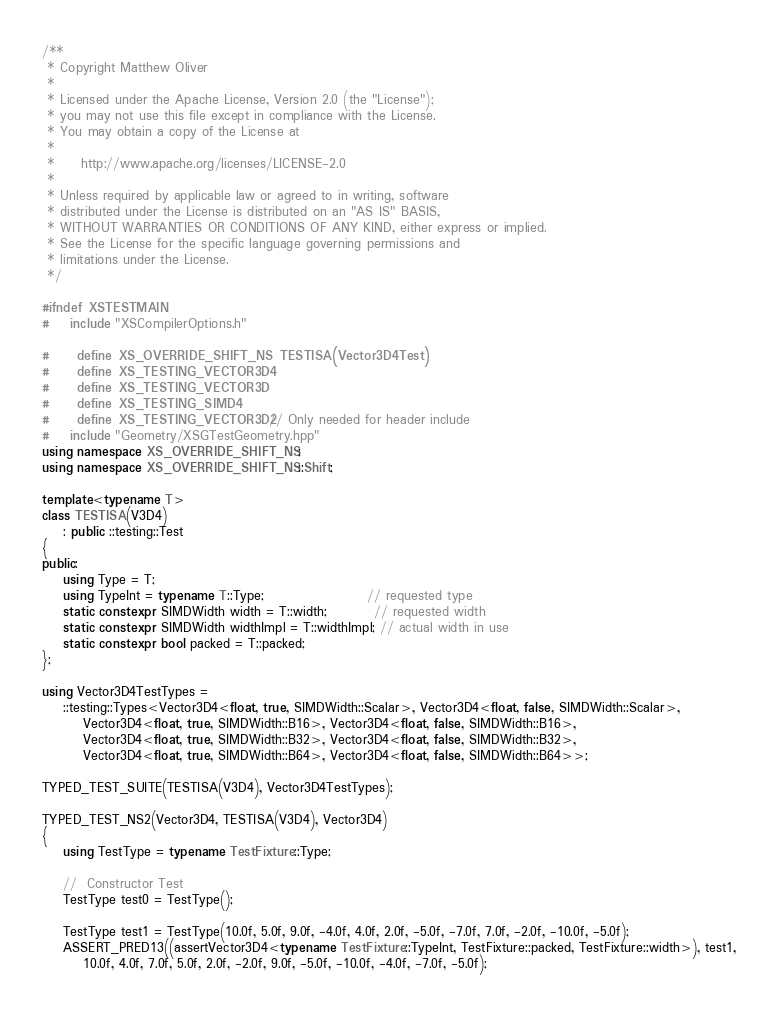<code> <loc_0><loc_0><loc_500><loc_500><_C++_>/**
 * Copyright Matthew Oliver
 *
 * Licensed under the Apache License, Version 2.0 (the "License");
 * you may not use this file except in compliance with the License.
 * You may obtain a copy of the License at
 *
 *     http://www.apache.org/licenses/LICENSE-2.0
 *
 * Unless required by applicable law or agreed to in writing, software
 * distributed under the License is distributed on an "AS IS" BASIS,
 * WITHOUT WARRANTIES OR CONDITIONS OF ANY KIND, either express or implied.
 * See the License for the specific language governing permissions and
 * limitations under the License.
 */

#ifndef XSTESTMAIN
#    include "XSCompilerOptions.h"

#    define XS_OVERRIDE_SHIFT_NS TESTISA(Vector3D4Test)
#    define XS_TESTING_VECTOR3D4
#    define XS_TESTING_VECTOR3D
#    define XS_TESTING_SIMD4
#    define XS_TESTING_VECTOR3D2 // Only needed for header include
#    include "Geometry/XSGTestGeometry.hpp"
using namespace XS_OVERRIDE_SHIFT_NS;
using namespace XS_OVERRIDE_SHIFT_NS::Shift;

template<typename T>
class TESTISA(V3D4)
    : public ::testing::Test
{
public:
    using Type = T;
    using TypeInt = typename T::Type;                    // requested type
    static constexpr SIMDWidth width = T::width;         // requested width
    static constexpr SIMDWidth widthImpl = T::widthImpl; // actual width in use
    static constexpr bool packed = T::packed;
};

using Vector3D4TestTypes =
    ::testing::Types<Vector3D4<float, true, SIMDWidth::Scalar>, Vector3D4<float, false, SIMDWidth::Scalar>,
        Vector3D4<float, true, SIMDWidth::B16>, Vector3D4<float, false, SIMDWidth::B16>,
        Vector3D4<float, true, SIMDWidth::B32>, Vector3D4<float, false, SIMDWidth::B32>,
        Vector3D4<float, true, SIMDWidth::B64>, Vector3D4<float, false, SIMDWidth::B64>>;

TYPED_TEST_SUITE(TESTISA(V3D4), Vector3D4TestTypes);

TYPED_TEST_NS2(Vector3D4, TESTISA(V3D4), Vector3D4)
{
    using TestType = typename TestFixture::Type;

    //  Constructor Test
    TestType test0 = TestType();

    TestType test1 = TestType(10.0f, 5.0f, 9.0f, -4.0f, 4.0f, 2.0f, -5.0f, -7.0f, 7.0f, -2.0f, -10.0f, -5.0f);
    ASSERT_PRED13((assertVector3D4<typename TestFixture::TypeInt, TestFixture::packed, TestFixture::width>), test1,
        10.0f, 4.0f, 7.0f, 5.0f, 2.0f, -2.0f, 9.0f, -5.0f, -10.0f, -4.0f, -7.0f, -5.0f);
</code> 